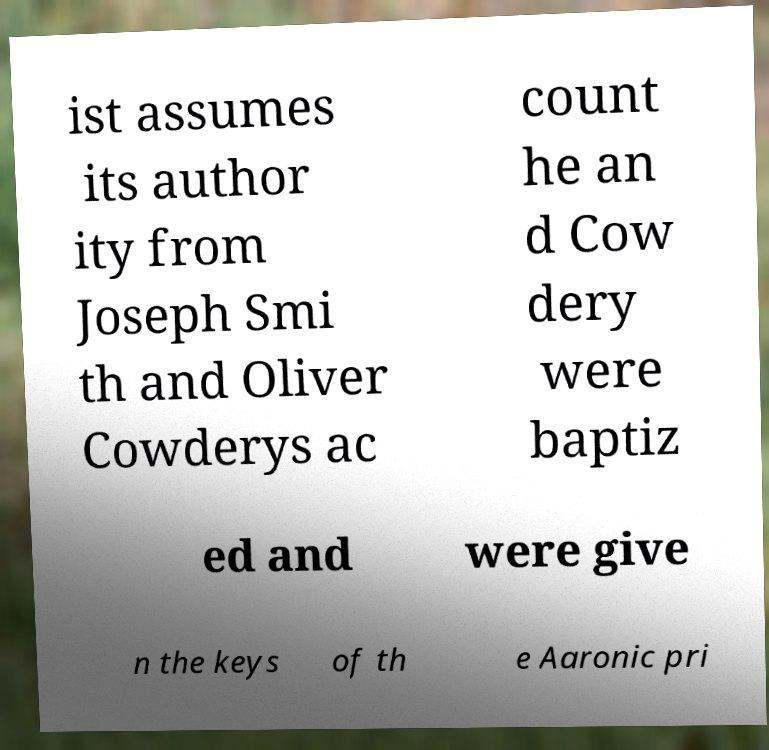For documentation purposes, I need the text within this image transcribed. Could you provide that? ist assumes its author ity from Joseph Smi th and Oliver Cowderys ac count he an d Cow dery were baptiz ed and were give n the keys of th e Aaronic pri 